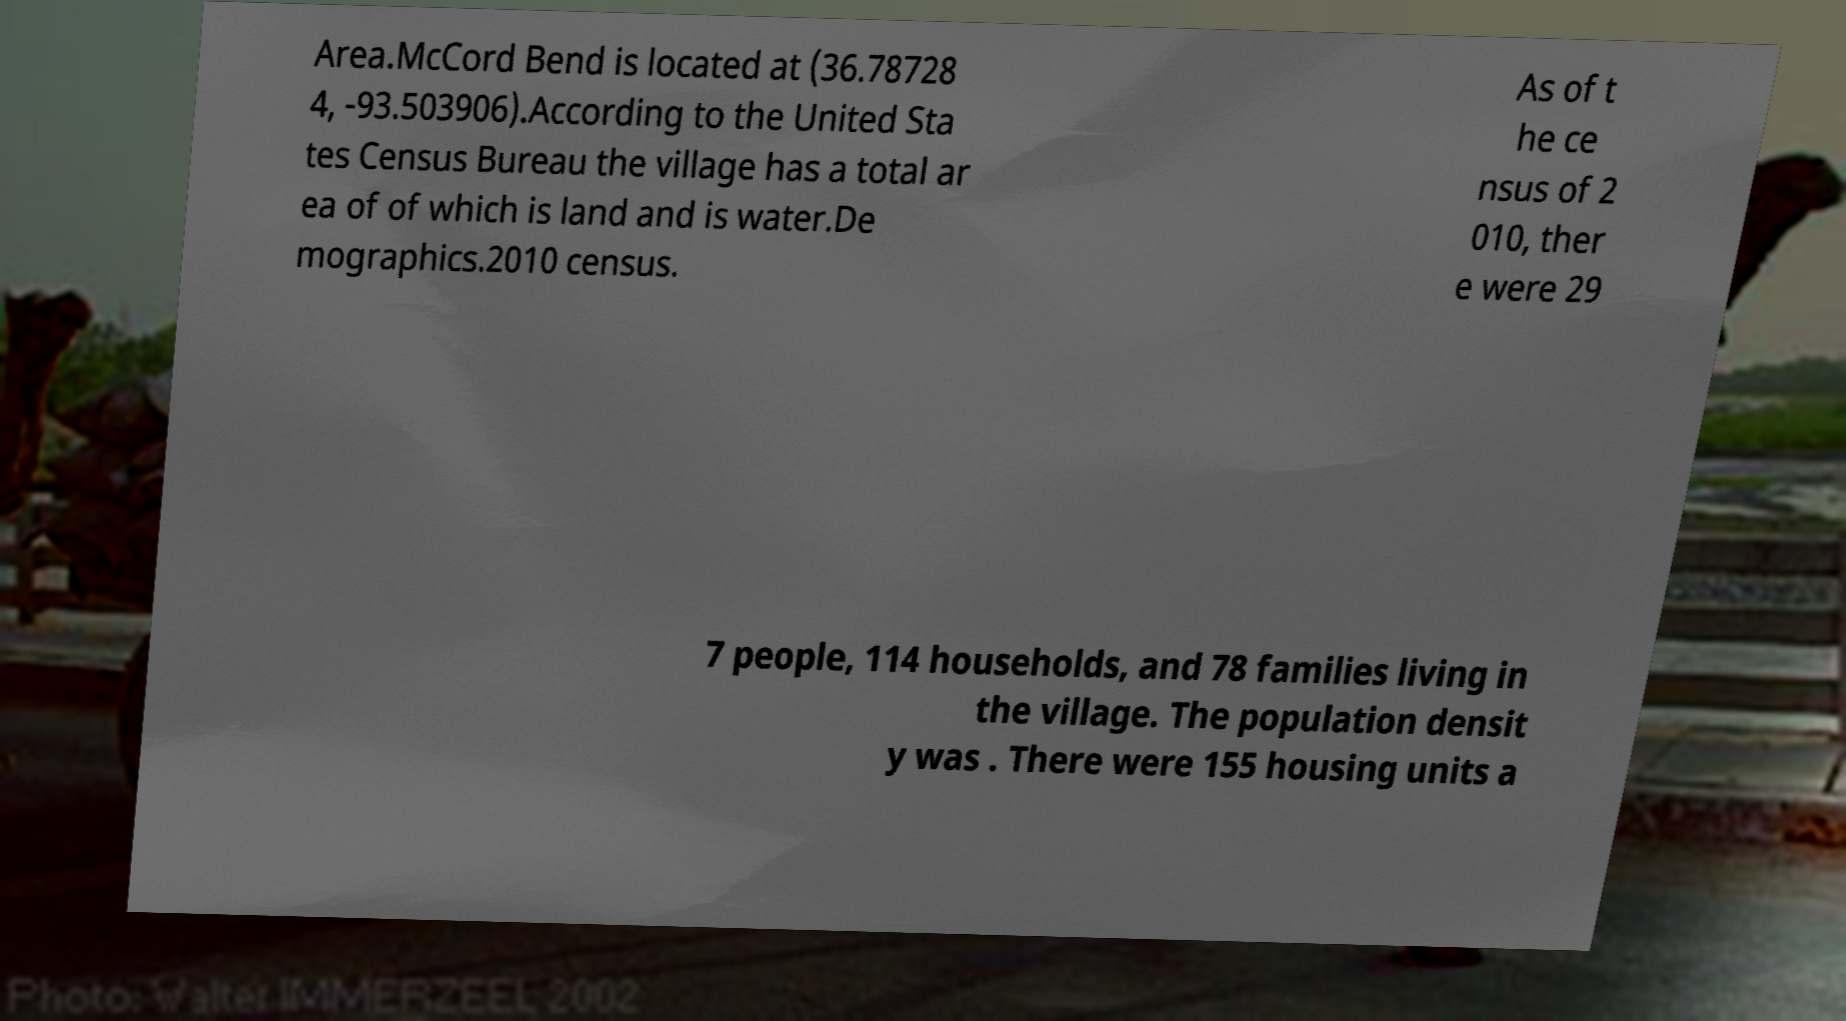What messages or text are displayed in this image? I need them in a readable, typed format. Area.McCord Bend is located at (36.78728 4, -93.503906).According to the United Sta tes Census Bureau the village has a total ar ea of of which is land and is water.De mographics.2010 census. As of t he ce nsus of 2 010, ther e were 29 7 people, 114 households, and 78 families living in the village. The population densit y was . There were 155 housing units a 